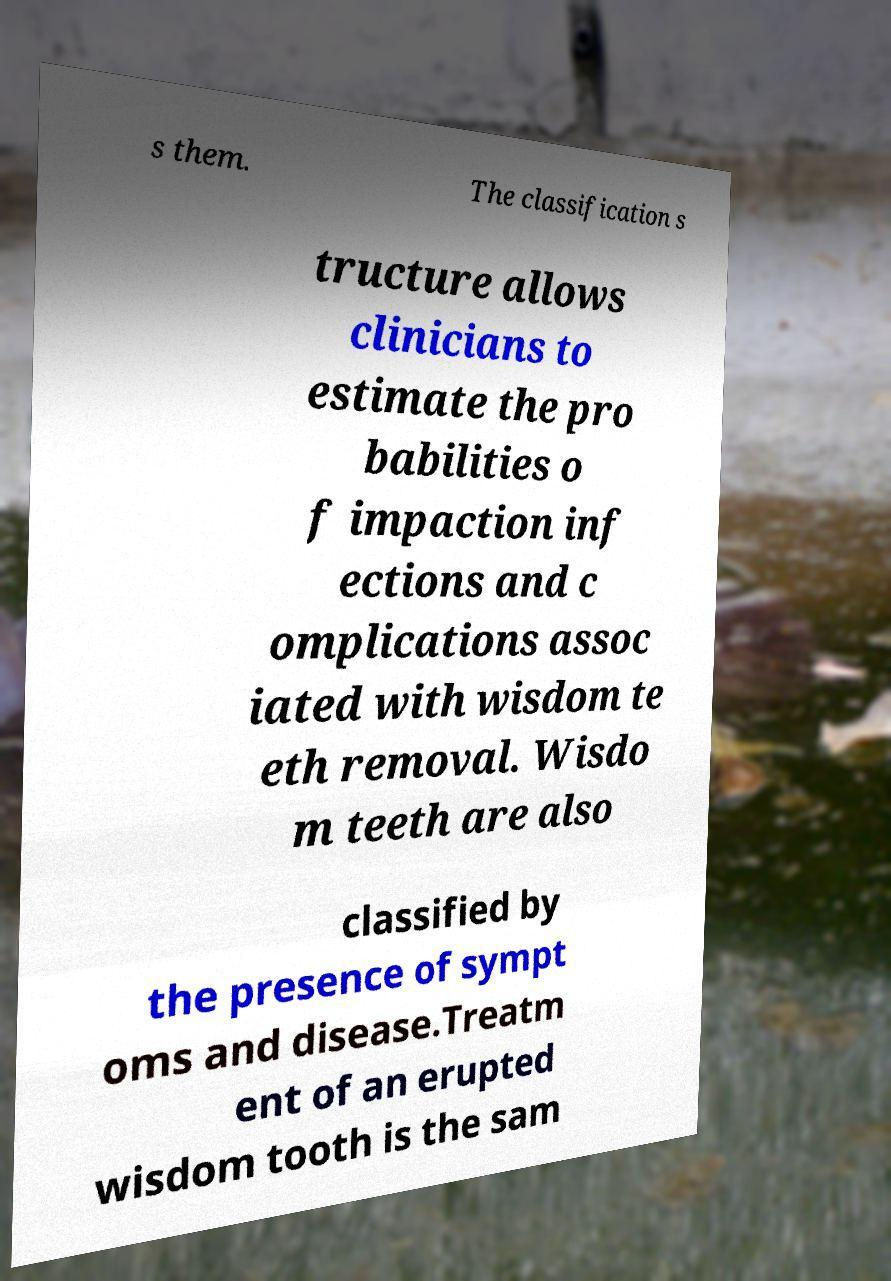Can you read and provide the text displayed in the image?This photo seems to have some interesting text. Can you extract and type it out for me? s them. The classification s tructure allows clinicians to estimate the pro babilities o f impaction inf ections and c omplications assoc iated with wisdom te eth removal. Wisdo m teeth are also classified by the presence of sympt oms and disease.Treatm ent of an erupted wisdom tooth is the sam 